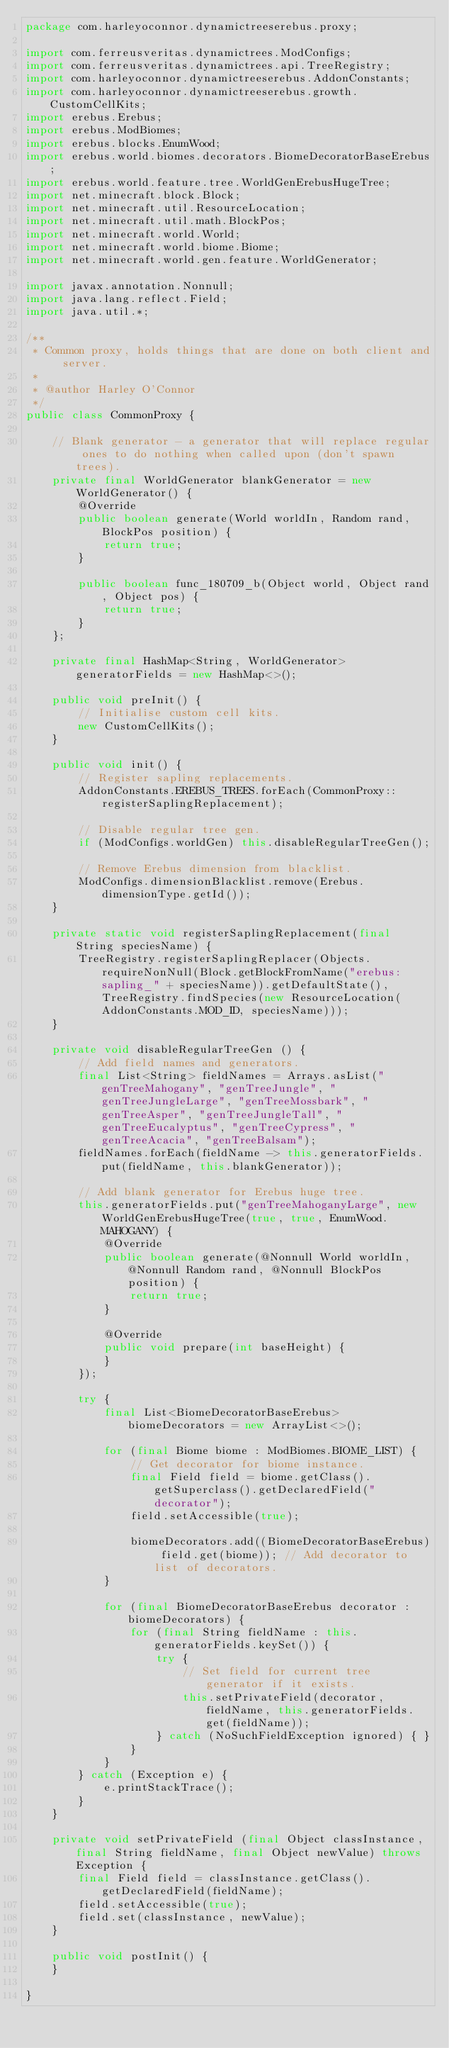<code> <loc_0><loc_0><loc_500><loc_500><_Java_>package com.harleyoconnor.dynamictreeserebus.proxy;

import com.ferreusveritas.dynamictrees.ModConfigs;
import com.ferreusveritas.dynamictrees.api.TreeRegistry;
import com.harleyoconnor.dynamictreeserebus.AddonConstants;
import com.harleyoconnor.dynamictreeserebus.growth.CustomCellKits;
import erebus.Erebus;
import erebus.ModBiomes;
import erebus.blocks.EnumWood;
import erebus.world.biomes.decorators.BiomeDecoratorBaseErebus;
import erebus.world.feature.tree.WorldGenErebusHugeTree;
import net.minecraft.block.Block;
import net.minecraft.util.ResourceLocation;
import net.minecraft.util.math.BlockPos;
import net.minecraft.world.World;
import net.minecraft.world.biome.Biome;
import net.minecraft.world.gen.feature.WorldGenerator;

import javax.annotation.Nonnull;
import java.lang.reflect.Field;
import java.util.*;

/**
 * Common proxy, holds things that are done on both client and server.
 *
 * @author Harley O'Connor
 */
public class CommonProxy {

	// Blank generator - a generator that will replace regular ones to do nothing when called upon (don't spawn trees).
	private final WorldGenerator blankGenerator = new WorldGenerator() {
		@Override
		public boolean generate(World worldIn, Random rand, BlockPos position) {
			return true;
		}

		public boolean func_180709_b(Object world, Object rand, Object pos) {
			return true;
		}
	};

	private final HashMap<String, WorldGenerator> generatorFields = new HashMap<>();

	public void preInit() {
		// Initialise custom cell kits.
		new CustomCellKits();
	}
	
	public void init() {
		// Register sapling replacements.
		AddonConstants.EREBUS_TREES.forEach(CommonProxy::registerSaplingReplacement);

		// Disable regular tree gen.
		if (ModConfigs.worldGen) this.disableRegularTreeGen();

		// Remove Erebus dimension from blacklist.
		ModConfigs.dimensionBlacklist.remove(Erebus.dimensionType.getId());
	}

	private static void registerSaplingReplacement(final String speciesName) {
		TreeRegistry.registerSaplingReplacer(Objects.requireNonNull(Block.getBlockFromName("erebus:sapling_" + speciesName)).getDefaultState(), TreeRegistry.findSpecies(new ResourceLocation(AddonConstants.MOD_ID, speciesName)));
	}

	private void disableRegularTreeGen () {
		// Add field names and generators.
		final List<String> fieldNames = Arrays.asList("genTreeMahogany", "genTreeJungle", "genTreeJungleLarge", "genTreeMossbark", "genTreeAsper", "genTreeJungleTall", "genTreeEucalyptus", "genTreeCypress", "genTreeAcacia", "genTreeBalsam");
		fieldNames.forEach(fieldName -> this.generatorFields.put(fieldName, this.blankGenerator));

		// Add blank generator for Erebus huge tree.
		this.generatorFields.put("genTreeMahoganyLarge", new WorldGenErebusHugeTree(true, true, EnumWood.MAHOGANY) {
			@Override
			public boolean generate(@Nonnull World worldIn, @Nonnull Random rand, @Nonnull BlockPos position) {
				return true;
			}

			@Override
			public void prepare(int baseHeight) {
			}
		});

		try {
			final List<BiomeDecoratorBaseErebus> biomeDecorators = new ArrayList<>();

			for (final Biome biome : ModBiomes.BIOME_LIST) {
				// Get decorator for biome instance.
				final Field field = biome.getClass().getSuperclass().getDeclaredField("decorator");
				field.setAccessible(true);

				biomeDecorators.add((BiomeDecoratorBaseErebus) field.get(biome)); // Add decorator to list of decorators.
			}

			for (final BiomeDecoratorBaseErebus decorator : biomeDecorators) {
				for (final String fieldName : this.generatorFields.keySet()) {
					try {
						// Set field for current tree generator if it exists.
						this.setPrivateField(decorator, fieldName, this.generatorFields.get(fieldName));
					} catch (NoSuchFieldException ignored) { }
				}
			}
		} catch (Exception e) {
			e.printStackTrace();
		}
	}

	private void setPrivateField (final Object classInstance, final String fieldName, final Object newValue) throws Exception {
		final Field field = classInstance.getClass().getDeclaredField(fieldName);
		field.setAccessible(true);
		field.set(classInstance, newValue);
	}

	public void postInit() {
	}

}
</code> 